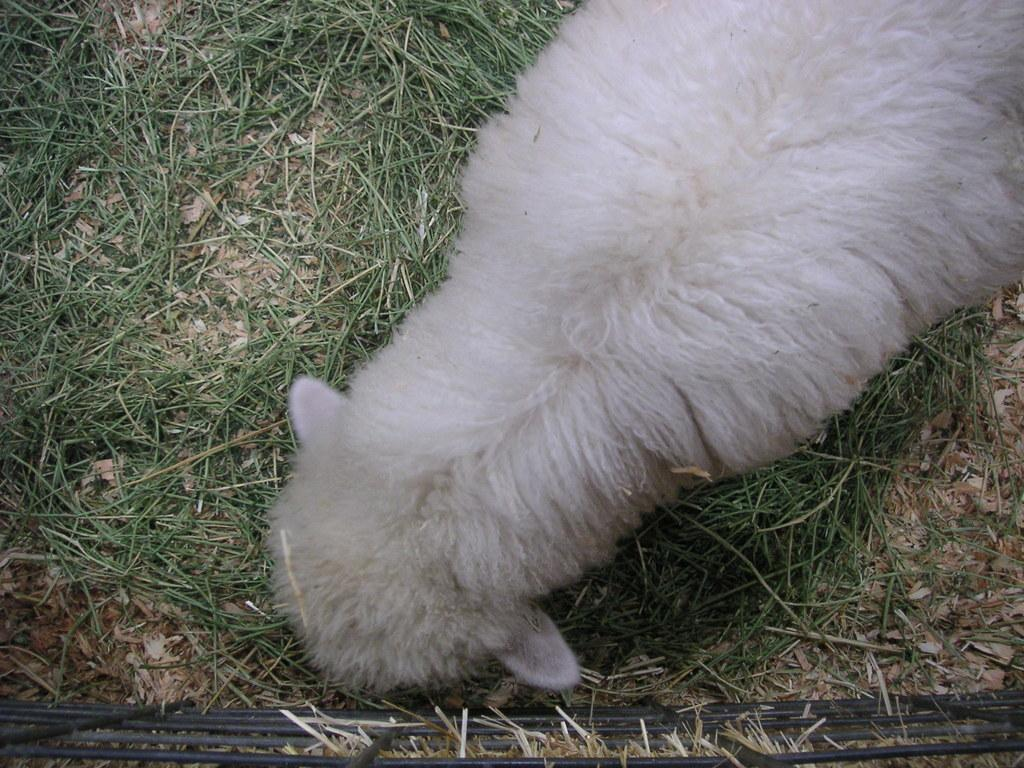What animal is the main subject of the picture? There is a white lamb in the picture. What is the lamb doing in the picture? The lamb is standing and eating grass. What type of vegetation is present at the bottom of the picture? There is grass at the bottom of the picture. What can be seen in the foreground of the picture? There is a railing in the foreground of the picture. What type of mint can be seen growing near the lamb in the picture? There is no mint visible in the picture; only grass is present. 